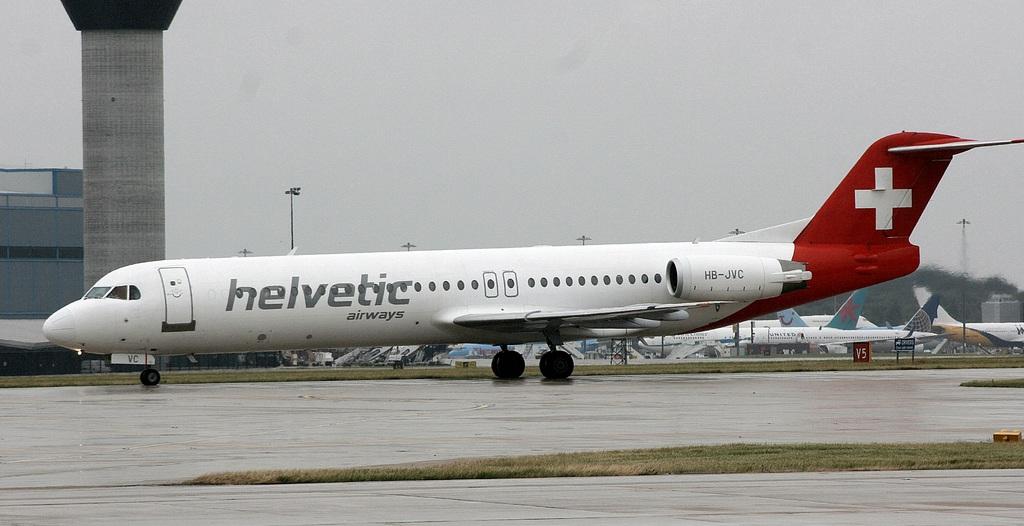What airways is this?
Give a very brief answer. Helvetic. 